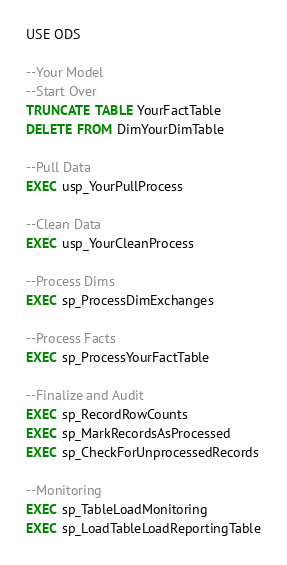Convert code to text. <code><loc_0><loc_0><loc_500><loc_500><_SQL_>USE ODS

--Your Model
--Start Over
TRUNCATE TABLE YourFactTable
DELETE FROM DimYourDimTable

--Pull Data
EXEC usp_YourPullProcess

--Clean Data
EXEC usp_YourCleanProcess

--Process Dims
EXEC sp_ProcessDimExchanges

--Process Facts
EXEC sp_ProcessYourFactTable

--Finalize and Audit
EXEC sp_RecordRowCounts
EXEC sp_MarkRecordsAsProcessed
EXEC sp_CheckForUnprocessedRecords

--Monitoring
EXEC sp_TableLoadMonitoring
EXEC sp_LoadTableLoadReportingTable

</code> 